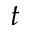Convert formula to latex. <formula><loc_0><loc_0><loc_500><loc_500>t</formula> 